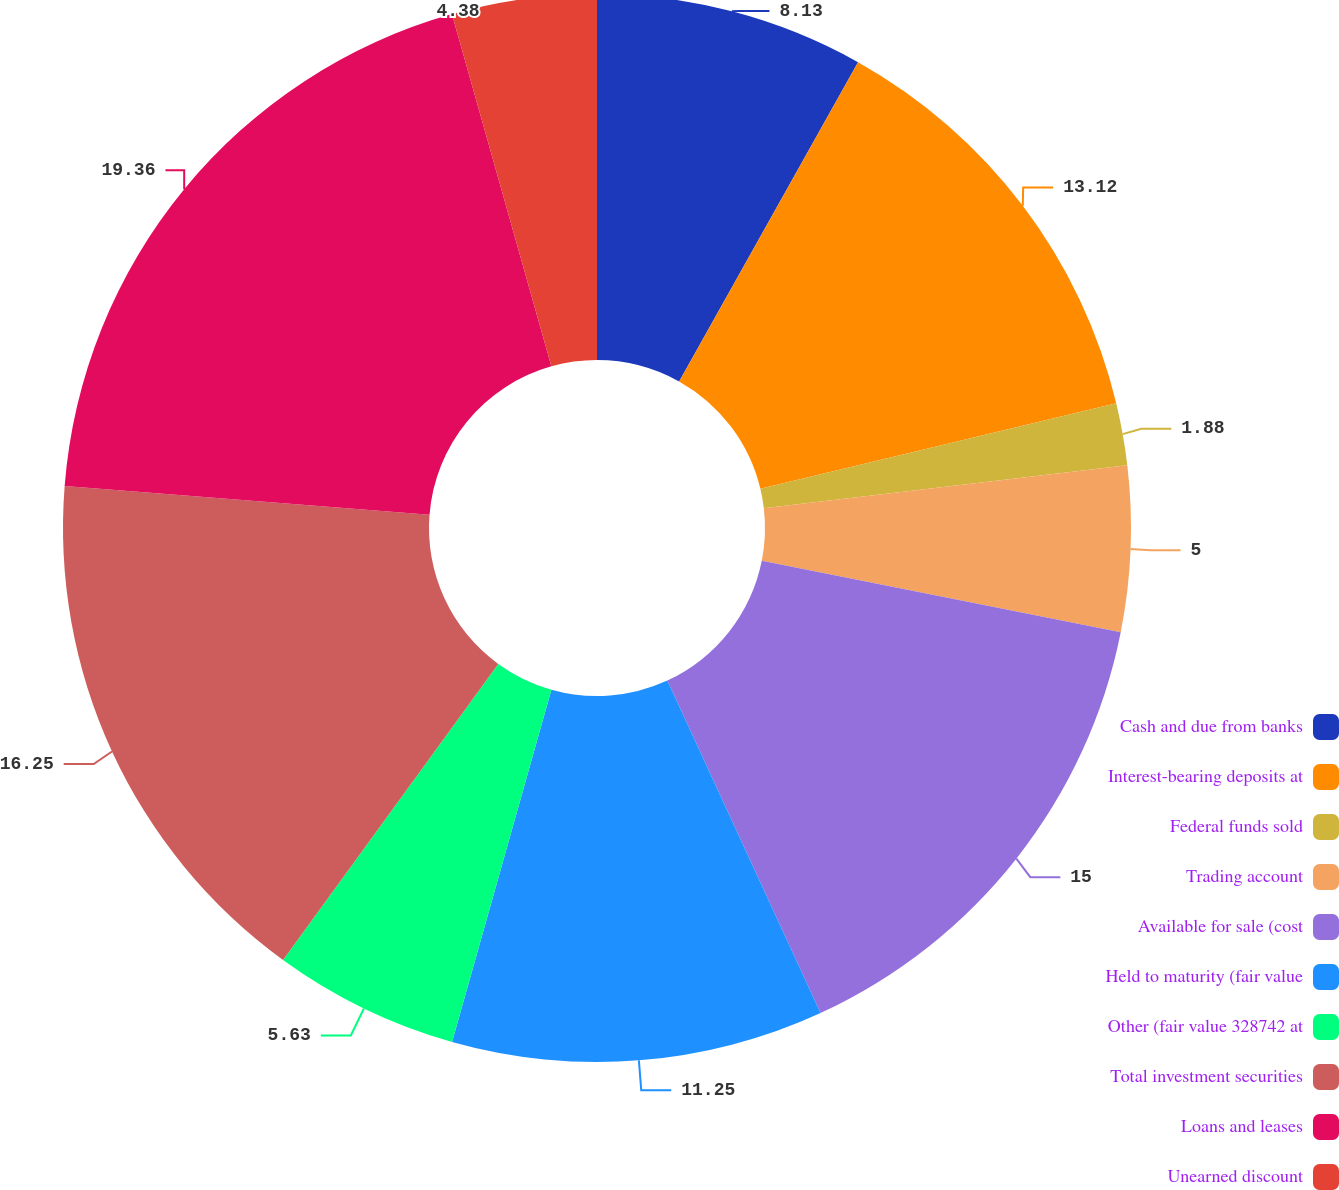Convert chart. <chart><loc_0><loc_0><loc_500><loc_500><pie_chart><fcel>Cash and due from banks<fcel>Interest-bearing deposits at<fcel>Federal funds sold<fcel>Trading account<fcel>Available for sale (cost<fcel>Held to maturity (fair value<fcel>Other (fair value 328742 at<fcel>Total investment securities<fcel>Loans and leases<fcel>Unearned discount<nl><fcel>8.13%<fcel>13.12%<fcel>1.88%<fcel>5.0%<fcel>15.0%<fcel>11.25%<fcel>5.63%<fcel>16.25%<fcel>19.37%<fcel>4.38%<nl></chart> 